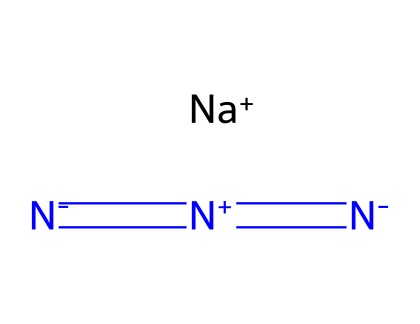What is the central atom in sodium azide? The chemical structure shows that there is a sodium atom (Na) as a cation, and the azide part consists of a chain of nitrogen atoms. The sodium serves as the central atom.
Answer: sodium How many nitrogen atoms are present in sodium azide? Inspecting the structure, there are three nitrogen atoms indicated in the azide group attached to the sodium ion, making the total count three.
Answer: three What type of bond connects the nitrogen atoms in sodium azide? The structure reveals that there are double bonds between the nitrogen atoms, as represented by the notation in the SMILES where '=' indicates double bonds.
Answer: double bonds What is the charge of the sodium ion in sodium azide? The SMILES representation indicates that sodium is in a cationic state denoted by [Na+], which shows that it has a positive charge.
Answer: positive What functional group is indicated by the structure of sodium azide? The chain of nitrogen atoms with the connection to sodium indicates the presence of an azide functional group, characterized typically by the sequence of nitrogen atoms.
Answer: azide What is the hybridization of the nitrogen atoms in sodium azide? Analyzing the nitrogen atoms in this structure, they are involved in multiple bonds (double bonds) which implies sp hybridization for each nitrogen atom, where nitrogen has a total of four electron domains.
Answer: sp 